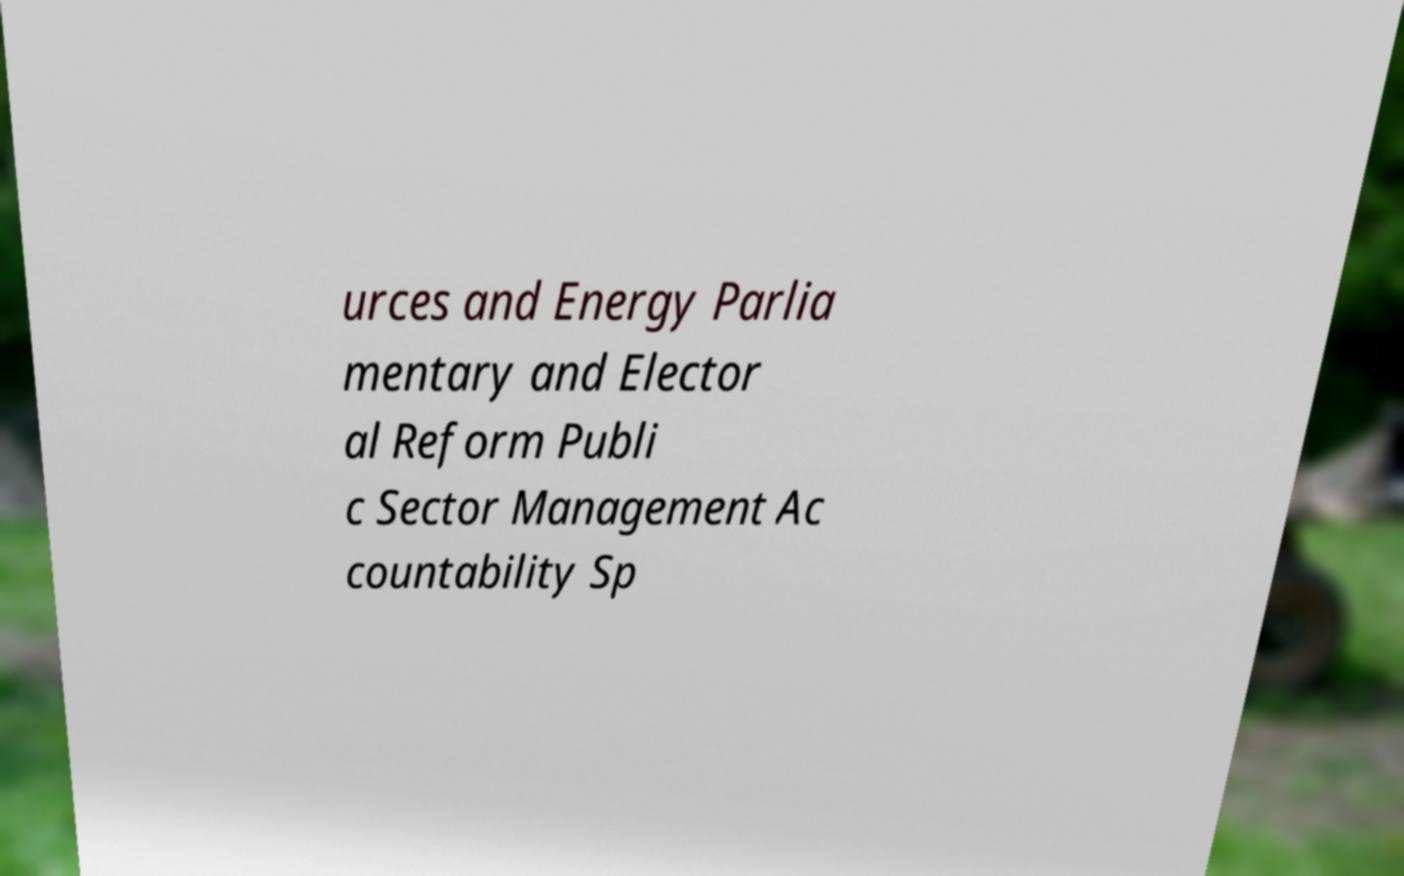Please identify and transcribe the text found in this image. urces and Energy Parlia mentary and Elector al Reform Publi c Sector Management Ac countability Sp 